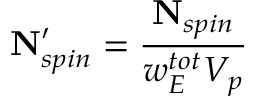<formula> <loc_0><loc_0><loc_500><loc_500>N _ { s p i n } ^ { \prime } = \frac { N _ { s p i n } } { w _ { E } ^ { t o t } V _ { p } }</formula> 